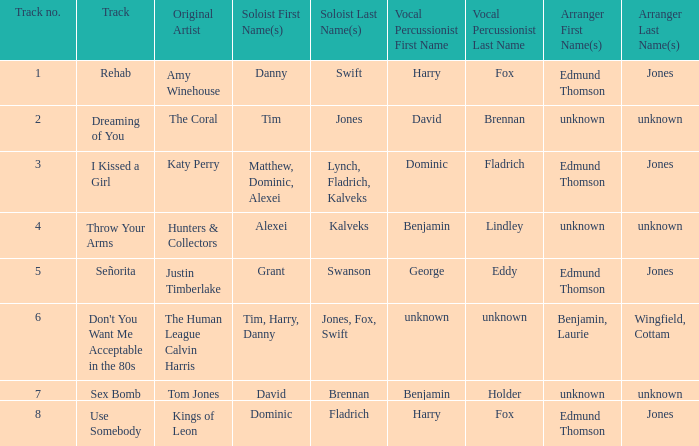Who is the arranger for "I KIssed a Girl"? Edmund Thomson Jones. 